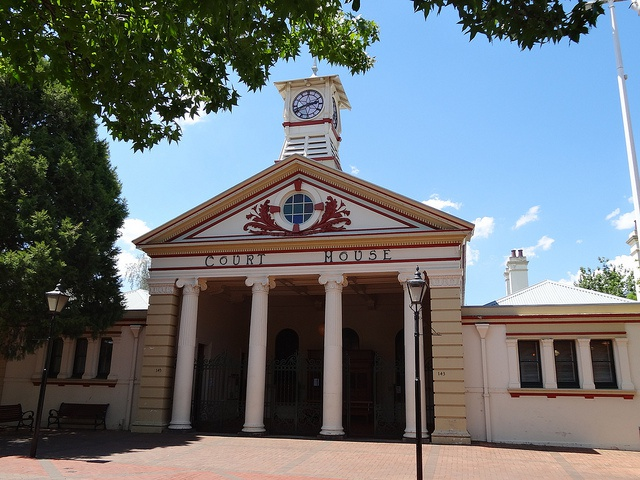Describe the objects in this image and their specific colors. I can see bench in black tones, bench in black tones, clock in black, gray, and darkgray tones, and clock in black, darkgray, and gray tones in this image. 